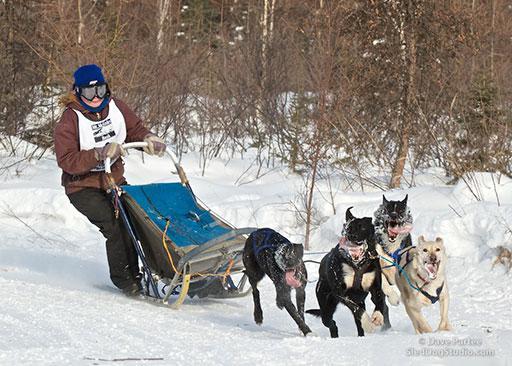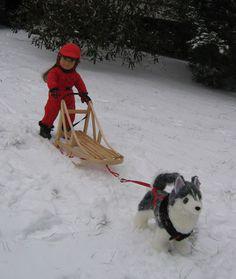The first image is the image on the left, the second image is the image on the right. Considering the images on both sides, is "A figure in red outerwear stands behind a rightward-angled sled with no passenger, pulled by at least one dog figure." valid? Answer yes or no. Yes. The first image is the image on the left, the second image is the image on the right. Analyze the images presented: Is the assertion "The person on the sled in the image on the right is wearing a red jacket." valid? Answer yes or no. Yes. 